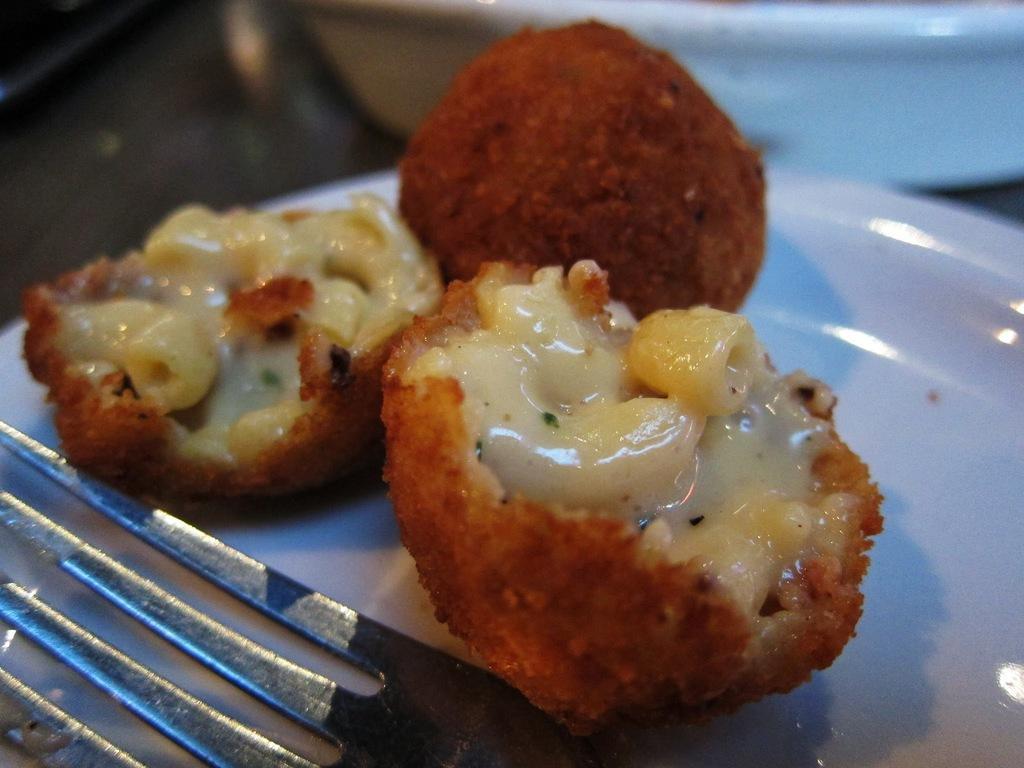Please provide a concise description of this image. In this image, we can see food in the white color palette, there is a fork in the plate. 